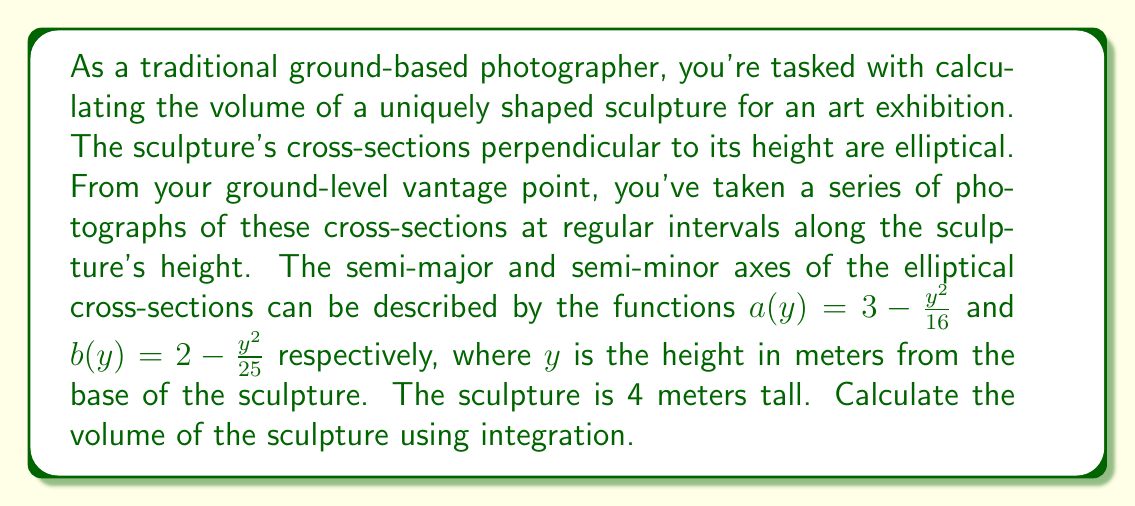Can you answer this question? To solve this problem, we'll use the method of integrating cross-sectional areas. The steps are as follows:

1) The area of an ellipse is given by $A = \pi ab$, where $a$ and $b$ are the semi-major and semi-minor axes.

2) In this case, $a$ and $b$ are functions of $y$:
   $a(y) = 3 - \frac{y^2}{16}$
   $b(y) = 2 - \frac{y^2}{25}$

3) The area of each cross-section as a function of $y$ is:
   $$A(y) = \pi a(y)b(y) = \pi (3 - \frac{y^2}{16})(2 - \frac{y^2}{25})$$

4) Expanding this expression:
   $$A(y) = \pi (6 - \frac{y^2}{8} - \frac{3y^2}{25} + \frac{y^4}{400})$$

5) The volume of the sculpture can be found by integrating this area from $y=0$ to $y=4$:
   $$V = \int_0^4 A(y) dy = \int_0^4 \pi (6 - \frac{y^2}{8} - \frac{3y^2}{25} + \frac{y^4}{400}) dy$$

6) Integrating term by term:
   $$V = \pi [\left.6y - \frac{y^3}{24} - \frac{y^3}{25} + \frac{y^5}{2000}\right|_0^4]$$

7) Evaluating the integral:
   $$V = \pi [(24 - \frac{64}{24} - \frac{64}{25} + \frac{1024}{2000}) - (0 - 0 - 0 + 0)]$$

8) Simplifying:
   $$V = \pi (24 - \frac{8}{3} - \frac{64}{25} + \frac{128}{250})$$
   $$V = \pi (24 - 2.67 - 2.56 + 0.512)$$
   $$V = 19.282\pi$$

Therefore, the volume of the sculpture is $19.282\pi$ cubic meters.
Answer: $19.282\pi$ cubic meters 